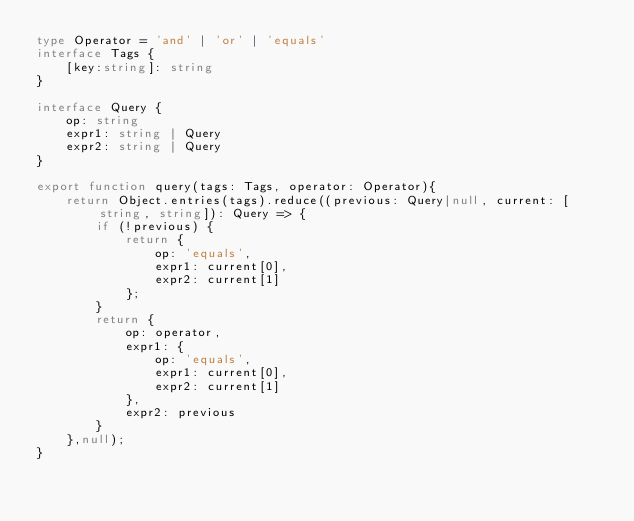<code> <loc_0><loc_0><loc_500><loc_500><_TypeScript_>type Operator = 'and' | 'or' | 'equals'
interface Tags {
    [key:string]: string
}

interface Query {
    op: string
    expr1: string | Query
    expr2: string | Query
}

export function query(tags: Tags, operator: Operator){
    return Object.entries(tags).reduce((previous: Query|null, current: [string, string]): Query => {
        if (!previous) {
            return {
                op: 'equals',
                expr1: current[0],
                expr2: current[1]
            };
        }
        return {
            op: operator,
            expr1: {
                op: 'equals',
                expr1: current[0],
                expr2: current[1]
            },
            expr2: previous
        }
    },null);
}
</code> 